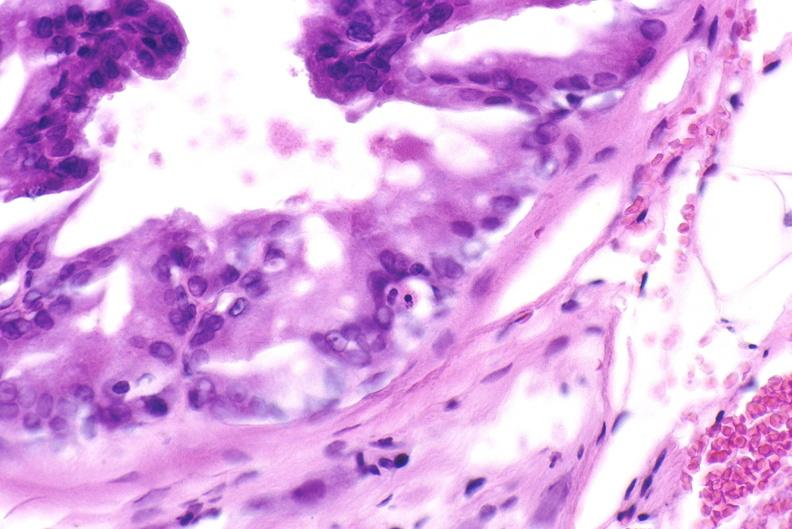does this image show apoptosis in prostate after orchiectomy?
Answer the question using a single word or phrase. Yes 